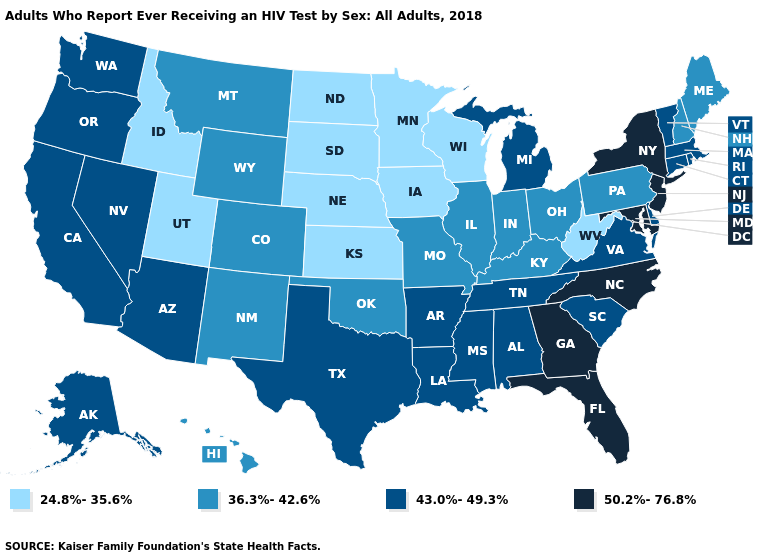Does Wyoming have a higher value than Iowa?
Quick response, please. Yes. What is the lowest value in states that border Georgia?
Concise answer only. 43.0%-49.3%. Name the states that have a value in the range 43.0%-49.3%?
Answer briefly. Alabama, Alaska, Arizona, Arkansas, California, Connecticut, Delaware, Louisiana, Massachusetts, Michigan, Mississippi, Nevada, Oregon, Rhode Island, South Carolina, Tennessee, Texas, Vermont, Virginia, Washington. What is the lowest value in states that border Rhode Island?
Write a very short answer. 43.0%-49.3%. Does the map have missing data?
Concise answer only. No. What is the value of Mississippi?
Be succinct. 43.0%-49.3%. Which states have the lowest value in the USA?
Quick response, please. Idaho, Iowa, Kansas, Minnesota, Nebraska, North Dakota, South Dakota, Utah, West Virginia, Wisconsin. What is the value of Massachusetts?
Give a very brief answer. 43.0%-49.3%. Name the states that have a value in the range 36.3%-42.6%?
Answer briefly. Colorado, Hawaii, Illinois, Indiana, Kentucky, Maine, Missouri, Montana, New Hampshire, New Mexico, Ohio, Oklahoma, Pennsylvania, Wyoming. What is the value of Connecticut?
Write a very short answer. 43.0%-49.3%. Name the states that have a value in the range 24.8%-35.6%?
Concise answer only. Idaho, Iowa, Kansas, Minnesota, Nebraska, North Dakota, South Dakota, Utah, West Virginia, Wisconsin. What is the value of Indiana?
Write a very short answer. 36.3%-42.6%. Among the states that border New Hampshire , which have the lowest value?
Short answer required. Maine. Does West Virginia have a higher value than Illinois?
Concise answer only. No. 